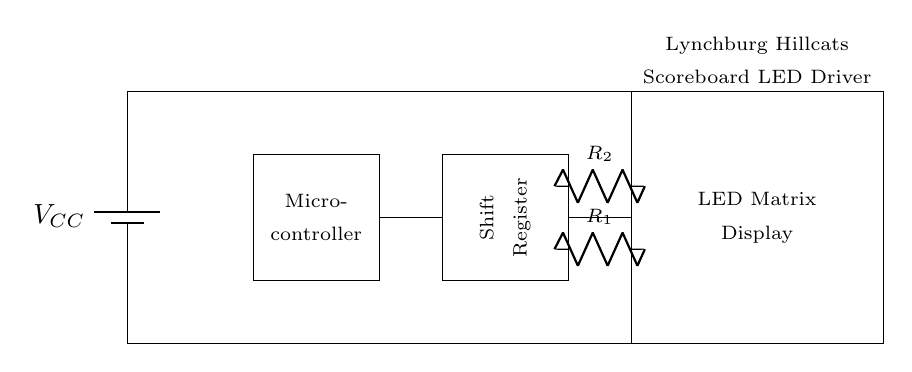What does the battery represent in this circuit? The battery in this circuit represents the power supply, labeled as VCC, providing voltage to the entire circuit to operate components like the microcontroller and LED matrix.
Answer: VCC What type of component is the shift register? The shift register is a digital storage device that is used to hold and shift data bits, facilitating the control of the LED display matrix by serial input/output.
Answer: Digital storage device How many resistors are in this circuit? The circuit diagram shows two resistors labeled R1 and R2, which are used for current limiting to protect the LEDs in the display from excessive current.
Answer: Two What is the main function of the microcontroller in this circuit? The microcontroller is responsible for processing data and controlling the LED matrix display by sending appropriate signals to the shift register, which then drives the LEDs.
Answer: Control signals What is the purpose of the current limiting resistors R1 and R2? R1 and R2 are included to limit the current flowing into the LED matrix display, preventing damage to the LEDs from excessive current and ensuring proper operation of the display.
Answer: Limit current How are the microcontroller and shift register connected? The microcontroller and shift register are connected by a direct line, allowing the microcontroller to send control signals to the shift register to manage LED output based on the scoreboard data.
Answer: Direct line 